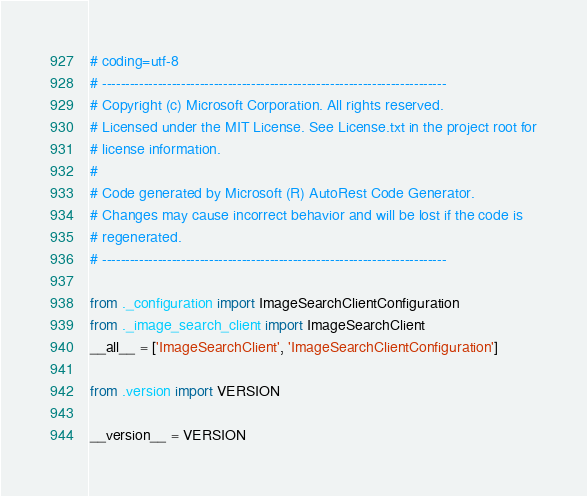<code> <loc_0><loc_0><loc_500><loc_500><_Python_># coding=utf-8
# --------------------------------------------------------------------------
# Copyright (c) Microsoft Corporation. All rights reserved.
# Licensed under the MIT License. See License.txt in the project root for
# license information.
#
# Code generated by Microsoft (R) AutoRest Code Generator.
# Changes may cause incorrect behavior and will be lost if the code is
# regenerated.
# --------------------------------------------------------------------------

from ._configuration import ImageSearchClientConfiguration
from ._image_search_client import ImageSearchClient
__all__ = ['ImageSearchClient', 'ImageSearchClientConfiguration']

from .version import VERSION

__version__ = VERSION

</code> 